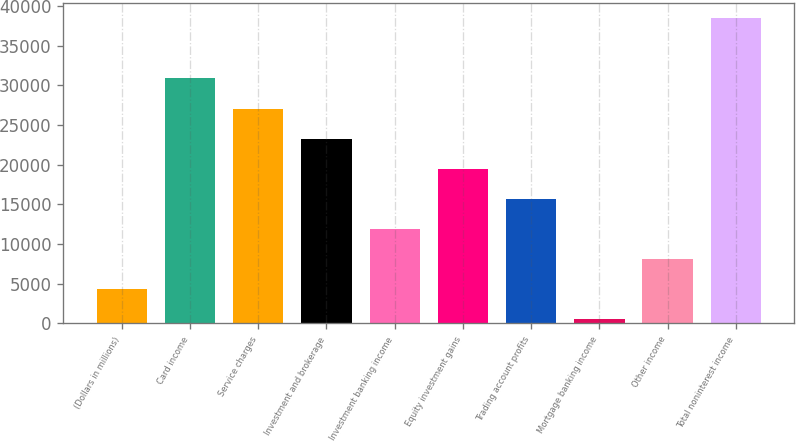Convert chart. <chart><loc_0><loc_0><loc_500><loc_500><bar_chart><fcel>(Dollars in millions)<fcel>Card income<fcel>Service charges<fcel>Investment and brokerage<fcel>Investment banking income<fcel>Equity investment gains<fcel>Trading account profits<fcel>Mortgage banking income<fcel>Other income<fcel>Total noninterest income<nl><fcel>4330.1<fcel>30853.8<fcel>27064.7<fcel>23275.6<fcel>11908.3<fcel>19486.5<fcel>15697.4<fcel>541<fcel>8119.2<fcel>38432<nl></chart> 